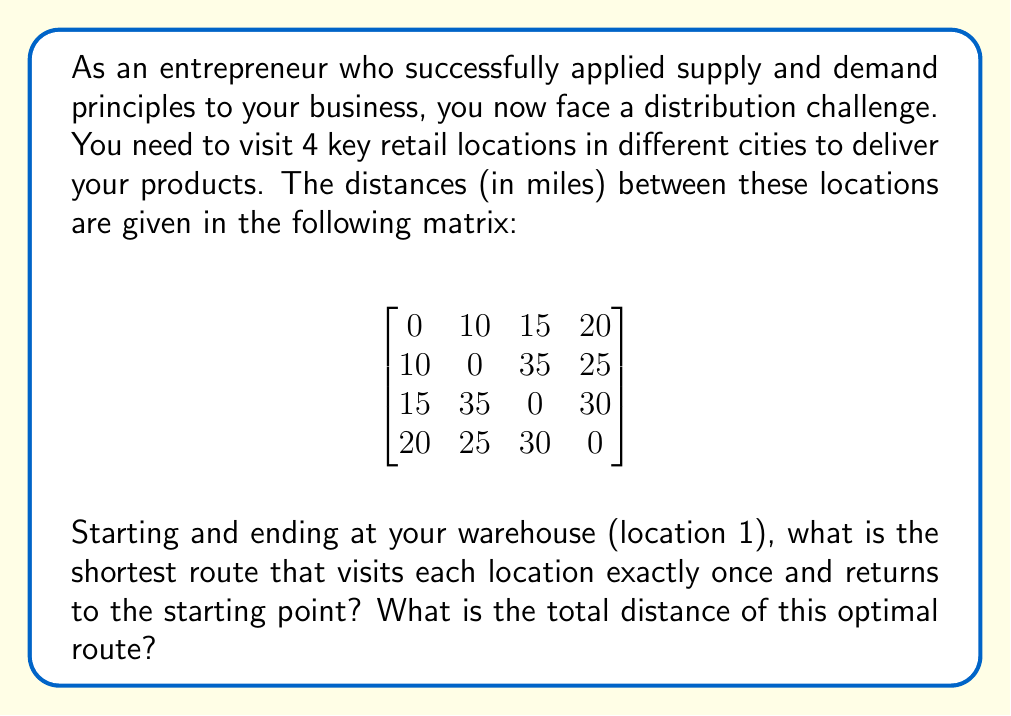Provide a solution to this math problem. To solve this Traveling Salesman Problem (TSP), we'll use the brute-force method, as the number of locations is small. Here are the steps:

1) List all possible permutations of the locations (excluding the start/end point):
   2-3-4, 2-4-3, 3-2-4, 3-4-2, 4-2-3, 4-3-2

2) Calculate the total distance for each permutation:

   1-2-3-4-1: $10 + 35 + 30 + 20 = 95$ miles
   1-2-4-3-1: $10 + 25 + 30 + 15 = 80$ miles
   1-3-2-4-1: $15 + 35 + 25 + 20 = 95$ miles
   1-3-4-2-1: $15 + 30 + 25 + 10 = 80$ miles
   1-4-2-3-1: $20 + 25 + 35 + 15 = 95$ miles
   1-4-3-2-1: $20 + 30 + 35 + 10 = 95$ miles

3) Identify the shortest route(s):
   Both 1-2-4-3-1 and 1-3-4-2-1 have the minimum distance of 80 miles.

4) Choose one of the optimal routes (e.g., 1-2-4-3-1).

This approach ensures that you visit each retail location once, minimizing travel time and fuel costs, which aligns with efficient supply chain management principles.
Answer: The shortest route is 1-2-4-3-1 (or 1-3-4-2-1), with a total distance of 80 miles. 